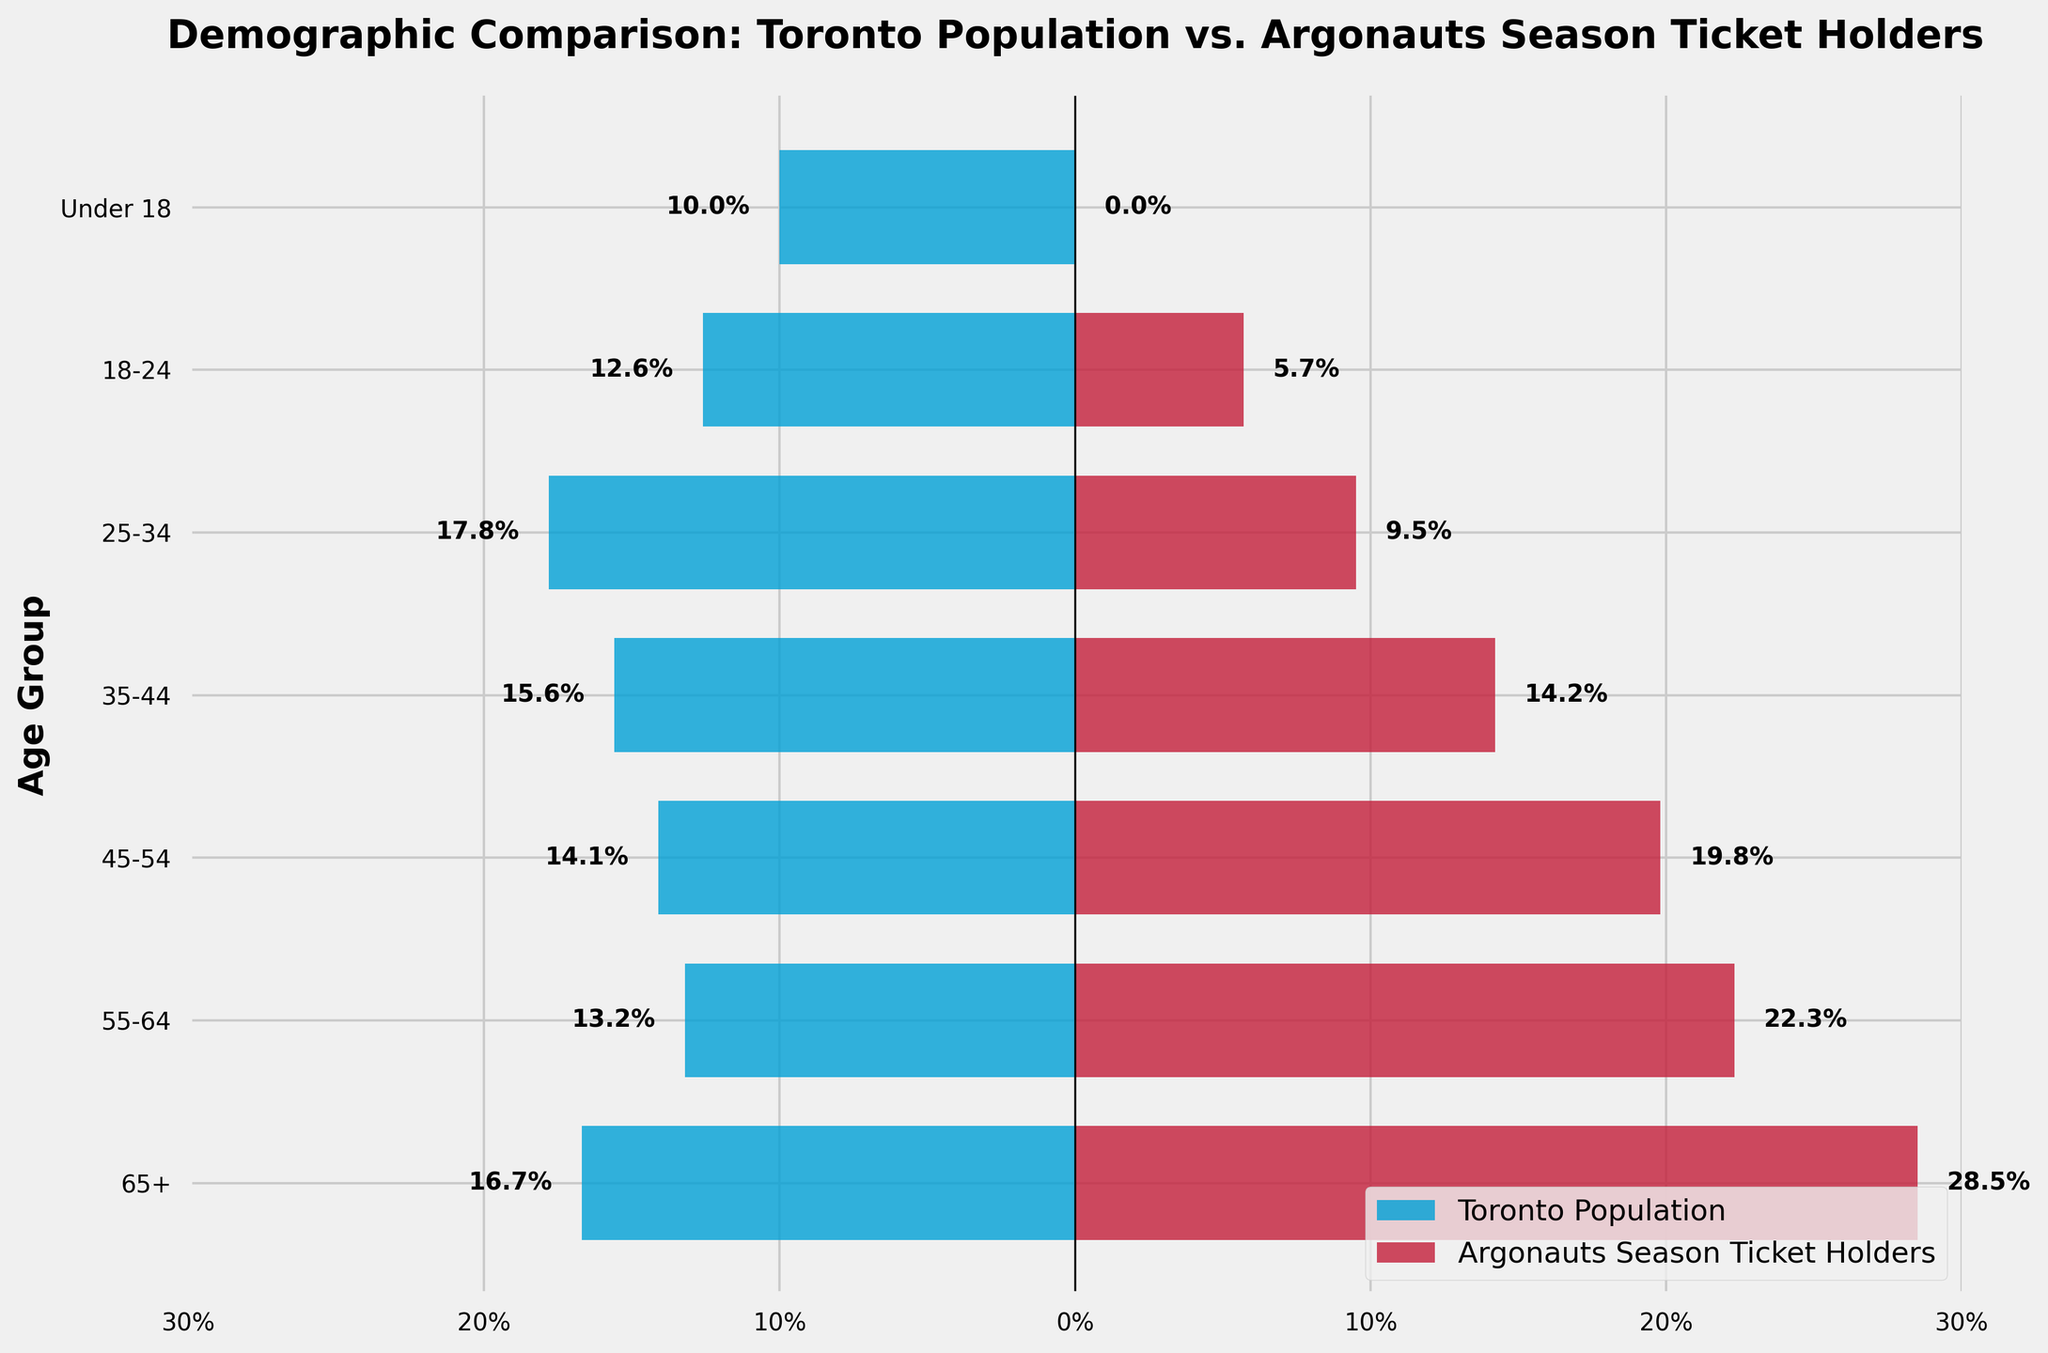What's the title of the figure? The title is typically at the top of the figure. Here, it says "Demographic Comparison: Toronto Population vs. Argonauts Season Ticket Holders".
Answer: Demographic Comparison: Toronto Population vs. Argonauts Season Ticket Holders What is the age group with the highest percentage of Toronto Population? From the figure, we can see the bar reaching the farthest left for Toronto Population, which corresponds to the 25–34 age group at 17.8%.
Answer: 25-34 Which age group has the highest percentage of Argonauts Season Ticket Holders? The bar reaching the farthest right for Argonauts Season Ticket Holders corresponds to the 65+ age group at 28.5%.
Answer: 65+ How does the percentage of Argonauts Season Ticket Holders aged 55-64 compare to those aged 18-24? The bar for 55–64 tickets holders at 22.3% is visibly higher than the bar for 18-24 at 5.7%, indicating a greater percentage.
Answer: Higher What is the percentage difference between the 65+ age group of the Toronto Population and the Argonauts Season Ticket Holders? The Toronto Population in the 65+ age group is at 16.7%, while the Argonauts Season Ticket Holders are at 28.5%. The difference is 28.5% - 16.7% = 11.8%.
Answer: 11.8% What age group shows the biggest difference in percentage between the Toronto Population and Argonauts Season Ticket Holders? By looking at the bars, the 25–34 age group shows a significant difference. Toronto Population is at 17.8%, while Argonauts Season Ticket Holders are at 9.5%, which is a difference of 17.8% - 9.5% = 8.3%.
Answer: 25-34 What percentage of Toronto's population is under 18 and how does that compare to the percentage of Argonauts Season Ticket Holders in the same age group? The percentage of Toronto's population under 18 is 10.0%, while there are 0% season ticket holders in this age group.
Answer: 10.0% and 0% On average, what is the percentage of Toronto Population across all age groups? The percentages for Toronto Population (16.7%, 13.2%, 14.1%, 15.6%, 17.8%, 12.6%, 10.0%) add up to 100%. The average is 100% divided by 7 age groups, which equals approximately 14.3%.
Answer: 14.3% In which age group do Argonauts Season Ticket Holders have the lowest percentage, and what is that percentage? Observing the bars, the 18-24 age group has the lowest ticket holders’ percentage at 5.7%.
Answer: 18-24, 5.7% 